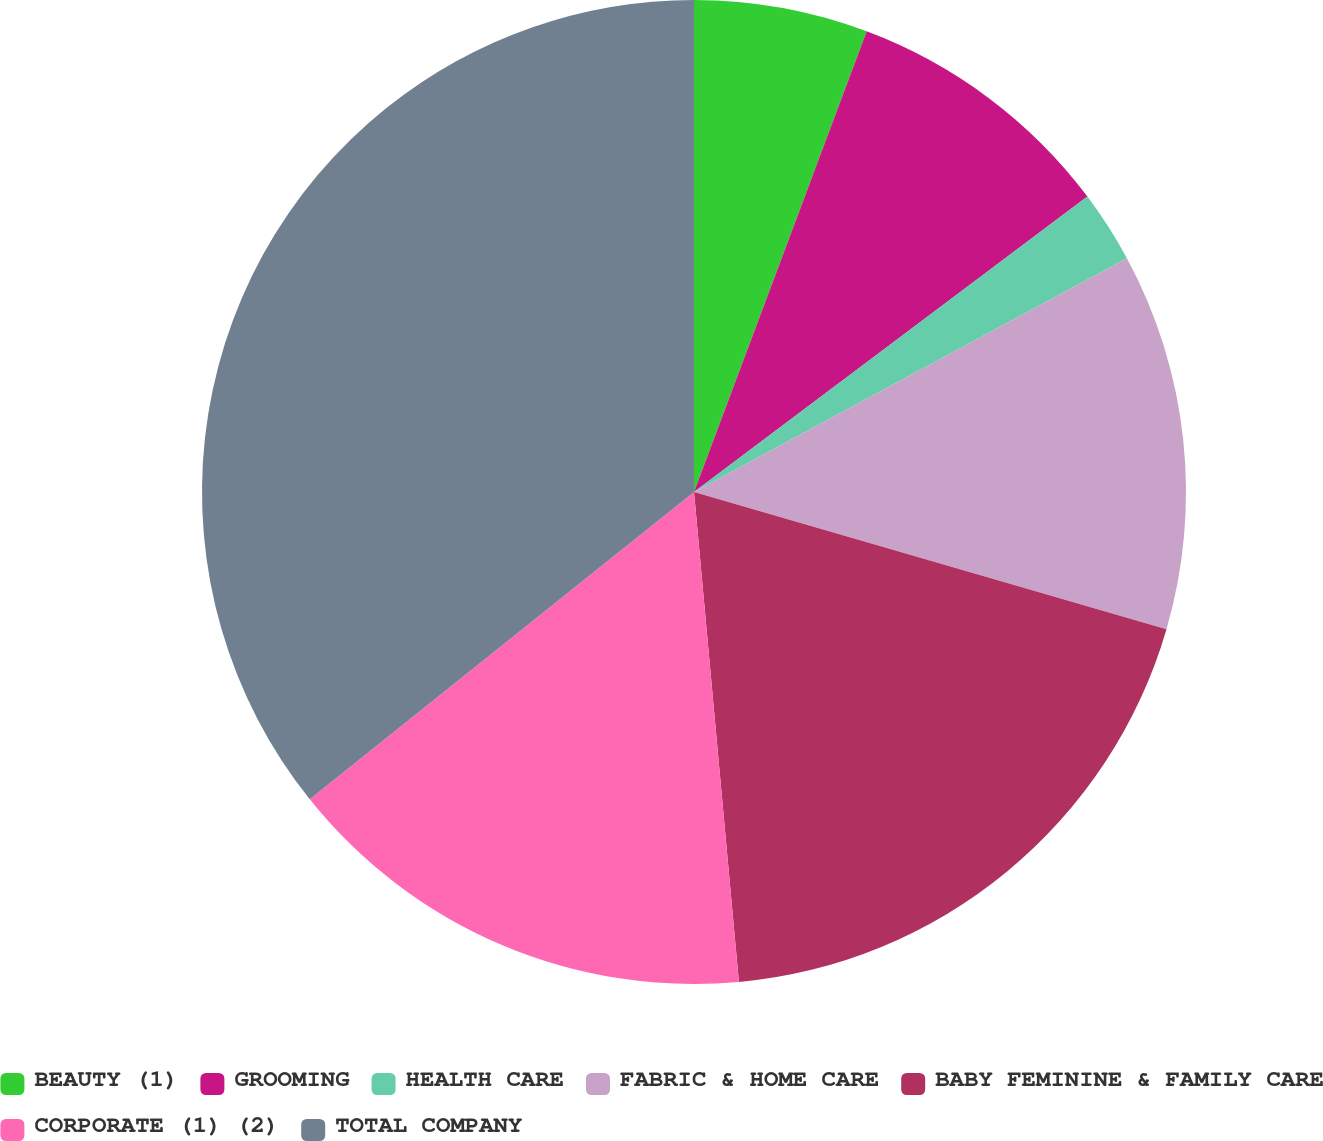Convert chart to OTSL. <chart><loc_0><loc_0><loc_500><loc_500><pie_chart><fcel>BEAUTY (1)<fcel>GROOMING<fcel>HEALTH CARE<fcel>FABRIC & HOME CARE<fcel>BABY FEMININE & FAMILY CARE<fcel>CORPORATE (1) (2)<fcel>TOTAL COMPANY<nl><fcel>5.71%<fcel>9.04%<fcel>2.37%<fcel>12.38%<fcel>19.05%<fcel>15.72%<fcel>35.74%<nl></chart> 